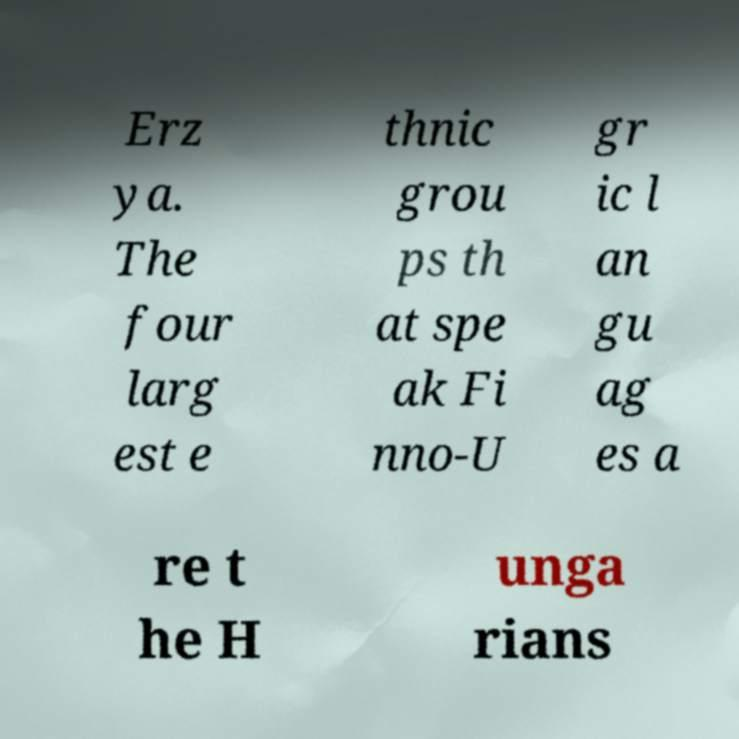For documentation purposes, I need the text within this image transcribed. Could you provide that? Erz ya. The four larg est e thnic grou ps th at spe ak Fi nno-U gr ic l an gu ag es a re t he H unga rians 